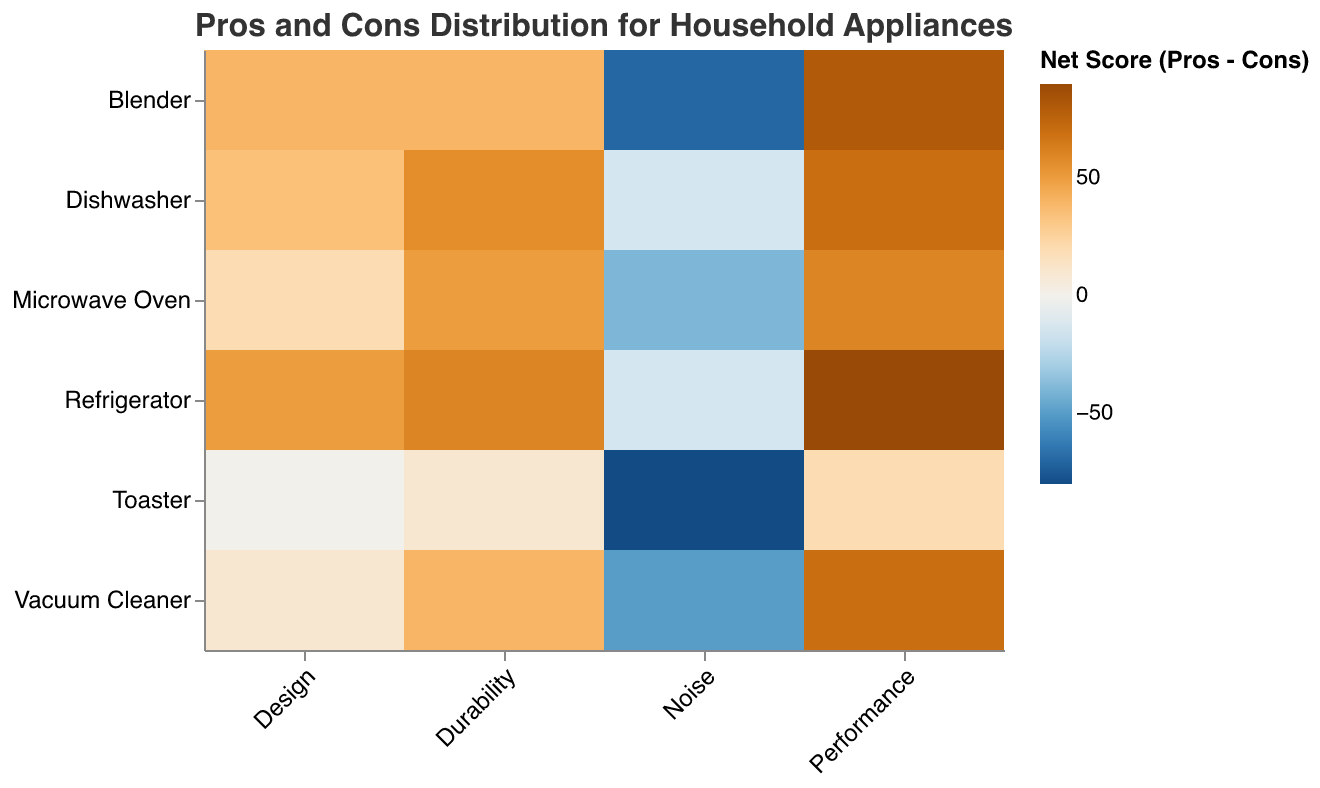What is the title of the heatmap? The title is located at the top of the chart and gives an overview of what the chart is presenting. It reads, "Pros and Cons Distribution for Household Appliances".
Answer: Pros and Cons Distribution for Household Appliances Which product has the highest net score for performance? To determine this, look at the 'Performance' column and identify the product with the darkest blue color, indicating the highest net score. The Refrigerator has the best performance with a net score of 90 (95 pros - 5 cons).
Answer: Refrigerator What is the general trend for the 'Noise' aspect across all products? By examining the 'Noise' column, we can see that most of the products have a higher number of cons than pros, leading to more orange and reddish hues. This indicates dissatisfaction with the noise levels for many products.
Answer: Generally negative (more cons than pros) Calculate the total net score for the Microwave Oven across all aspects. Sum the net scores across all aspects for Microwave Oven. The net scores are (80-20) + (75-25) + (25-65) + (55-35) = 60 + 50 - 40 + 20 = 90.
Answer: 90 Which product has the most balanced feedback for 'Design', i.e., an equal number of pros and cons? Look at the 'Design' column for the products where the color is neutral, possibly light brown or yellow indicating a net score of 0. The Toaster has equal numbers of pros and cons (50-50).
Answer: Toaster How does the net score for 'Durability' in the Dishwashers compare to that in the Blenders? Examine the color intensity in the 'Durability' aspect for both Dishwashers and Blenders. The Dishwasher has a net score of 78-22 = 56, and the Blender has a net score of 70-30 = 40. Therefore, Dishwashers have a higher net score for durability.
Answer: Dishwashers have a higher net score What can you infer about common pros for the 'Performance' aspect in household appliances? Look at the 'Performance' column and observe that almost all products show dark blue colors, indicating a high number of pros relative to cons. This suggests that performance is generally seen as a strong point for these appliances.
Answer: Performance is generally a strong point Which product has the worst feedback for 'Noise'? Find the darkest orange or red color in the 'Noise' column, indicating the lowest net score. The Toaster has the worst feedback for noise with a net score of -80 (10 pros - 90 cons).
Answer: Toaster What is the net score difference between the best and worst aspects of the Vacuum Cleaner? Identify the highest and lowest values for Vacuum Cleaner across all aspects. The highest net score is for Performance (85-15=70), and the lowest is for Noise (20-70=-50). The net difference is 70 - (-50) = 120.
Answer: 120 Which aspect of the Blender has the least positive feedback? Examine the Blender row and identify the column with the darkest orange or red color, which would indicate the lowest net score. The 'Noise' aspect has the least positive feedback with a net score of -70 (15 pros - 85 cons).
Answer: Noise 